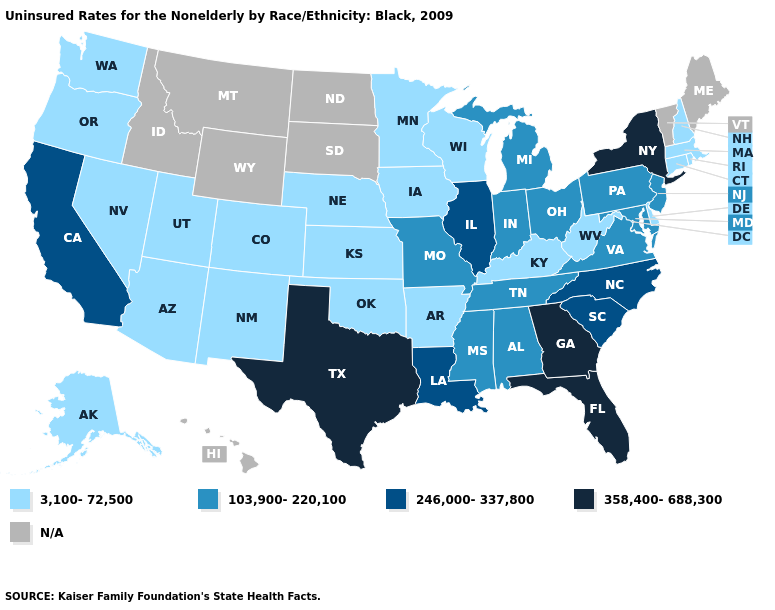Does Georgia have the highest value in the USA?
Short answer required. Yes. Is the legend a continuous bar?
Give a very brief answer. No. Name the states that have a value in the range N/A?
Concise answer only. Hawaii, Idaho, Maine, Montana, North Dakota, South Dakota, Vermont, Wyoming. Which states have the lowest value in the USA?
Give a very brief answer. Alaska, Arizona, Arkansas, Colorado, Connecticut, Delaware, Iowa, Kansas, Kentucky, Massachusetts, Minnesota, Nebraska, Nevada, New Hampshire, New Mexico, Oklahoma, Oregon, Rhode Island, Utah, Washington, West Virginia, Wisconsin. What is the lowest value in states that border Arizona?
Keep it brief. 3,100-72,500. Does the map have missing data?
Answer briefly. Yes. Does the first symbol in the legend represent the smallest category?
Short answer required. Yes. What is the value of Tennessee?
Concise answer only. 103,900-220,100. Name the states that have a value in the range N/A?
Concise answer only. Hawaii, Idaho, Maine, Montana, North Dakota, South Dakota, Vermont, Wyoming. Name the states that have a value in the range 246,000-337,800?
Concise answer only. California, Illinois, Louisiana, North Carolina, South Carolina. Name the states that have a value in the range 246,000-337,800?
Short answer required. California, Illinois, Louisiana, North Carolina, South Carolina. What is the lowest value in the USA?
Answer briefly. 3,100-72,500. Name the states that have a value in the range 3,100-72,500?
Quick response, please. Alaska, Arizona, Arkansas, Colorado, Connecticut, Delaware, Iowa, Kansas, Kentucky, Massachusetts, Minnesota, Nebraska, Nevada, New Hampshire, New Mexico, Oklahoma, Oregon, Rhode Island, Utah, Washington, West Virginia, Wisconsin. What is the value of Idaho?
Answer briefly. N/A. 